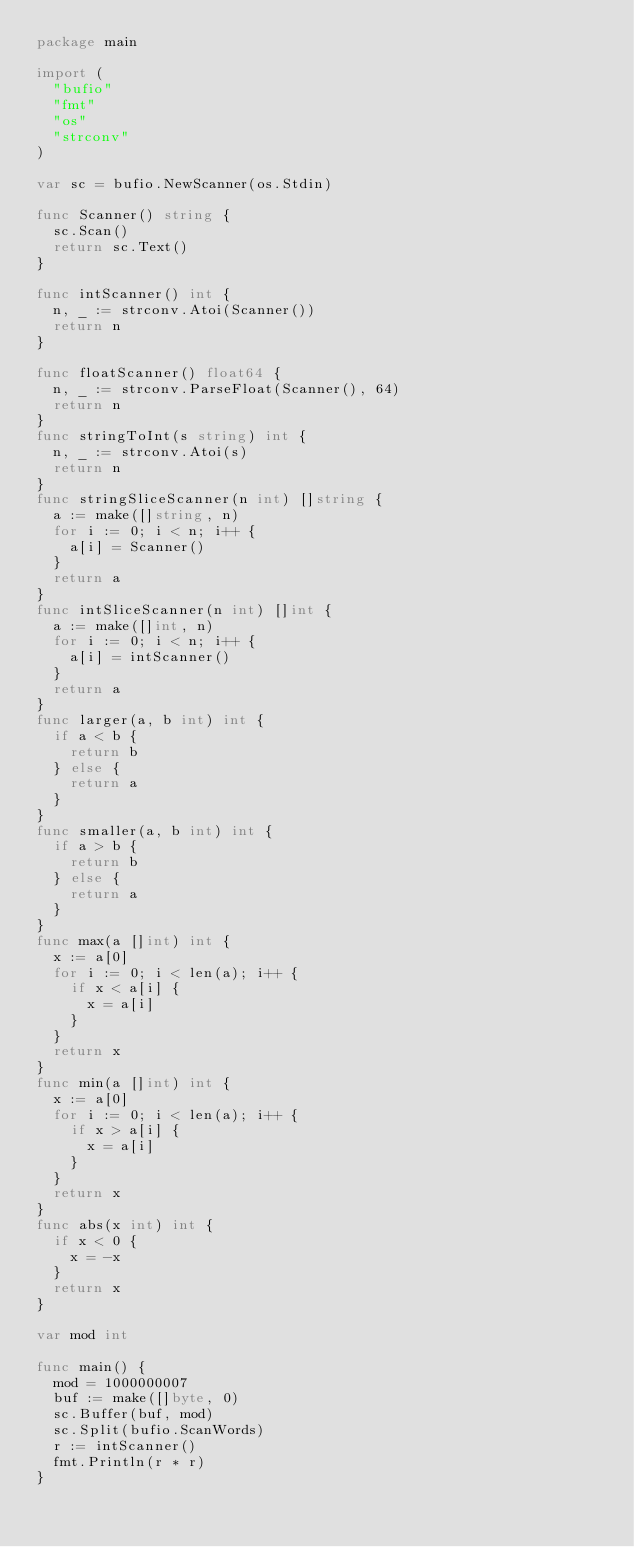Convert code to text. <code><loc_0><loc_0><loc_500><loc_500><_Go_>package main

import (
	"bufio"
	"fmt"
	"os"
	"strconv"
)

var sc = bufio.NewScanner(os.Stdin)

func Scanner() string {
	sc.Scan()
	return sc.Text()
}

func intScanner() int {
	n, _ := strconv.Atoi(Scanner())
	return n
}

func floatScanner() float64 {
	n, _ := strconv.ParseFloat(Scanner(), 64)
	return n
}
func stringToInt(s string) int {
	n, _ := strconv.Atoi(s)
	return n
}
func stringSliceScanner(n int) []string {
	a := make([]string, n)
	for i := 0; i < n; i++ {
		a[i] = Scanner()
	}
	return a
}
func intSliceScanner(n int) []int {
	a := make([]int, n)
	for i := 0; i < n; i++ {
		a[i] = intScanner()
	}
	return a
}
func larger(a, b int) int {
	if a < b {
		return b
	} else {
		return a
	}
}
func smaller(a, b int) int {
	if a > b {
		return b
	} else {
		return a
	}
}
func max(a []int) int {
	x := a[0]
	for i := 0; i < len(a); i++ {
		if x < a[i] {
			x = a[i]
		}
	}
	return x
}
func min(a []int) int {
	x := a[0]
	for i := 0; i < len(a); i++ {
		if x > a[i] {
			x = a[i]
		}
	}
	return x
}
func abs(x int) int {
	if x < 0 {
		x = -x
	}
	return x
}

var mod int

func main() {
	mod = 1000000007
	buf := make([]byte, 0)
	sc.Buffer(buf, mod)
	sc.Split(bufio.ScanWords)
	r := intScanner()
	fmt.Println(r * r)
}
</code> 